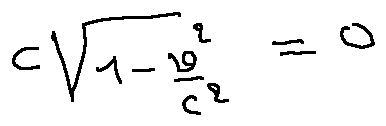<formula> <loc_0><loc_0><loc_500><loc_500>c \sqrt { 1 - \frac { v ^ { 2 } } { c ^ { 2 } } } = 0</formula> 